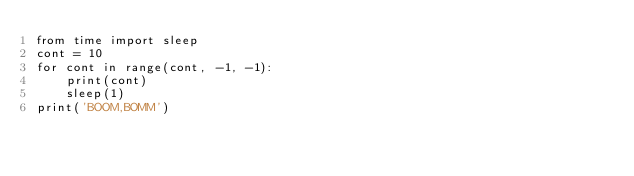Convert code to text. <code><loc_0><loc_0><loc_500><loc_500><_Python_>from time import sleep
cont = 10
for cont in range(cont, -1, -1):
    print(cont)
    sleep(1)
print('BOOM,BOMM')</code> 